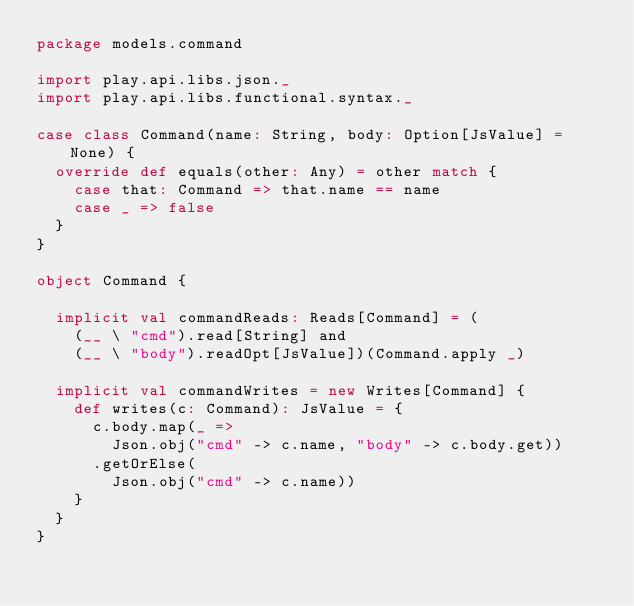Convert code to text. <code><loc_0><loc_0><loc_500><loc_500><_Scala_>package models.command

import play.api.libs.json._
import play.api.libs.functional.syntax._

case class Command(name: String, body: Option[JsValue] = None) {
  override def equals(other: Any) = other match {
    case that: Command => that.name == name
    case _ => false
  }
}

object Command {

  implicit val commandReads: Reads[Command] = (
    (__ \ "cmd").read[String] and
    (__ \ "body").readOpt[JsValue])(Command.apply _)

  implicit val commandWrites = new Writes[Command] {
    def writes(c: Command): JsValue = {
      c.body.map(_ => 
        Json.obj("cmd" -> c.name, "body" -> c.body.get))
      .getOrElse(
        Json.obj("cmd" -> c.name))
    }
  }
}</code> 